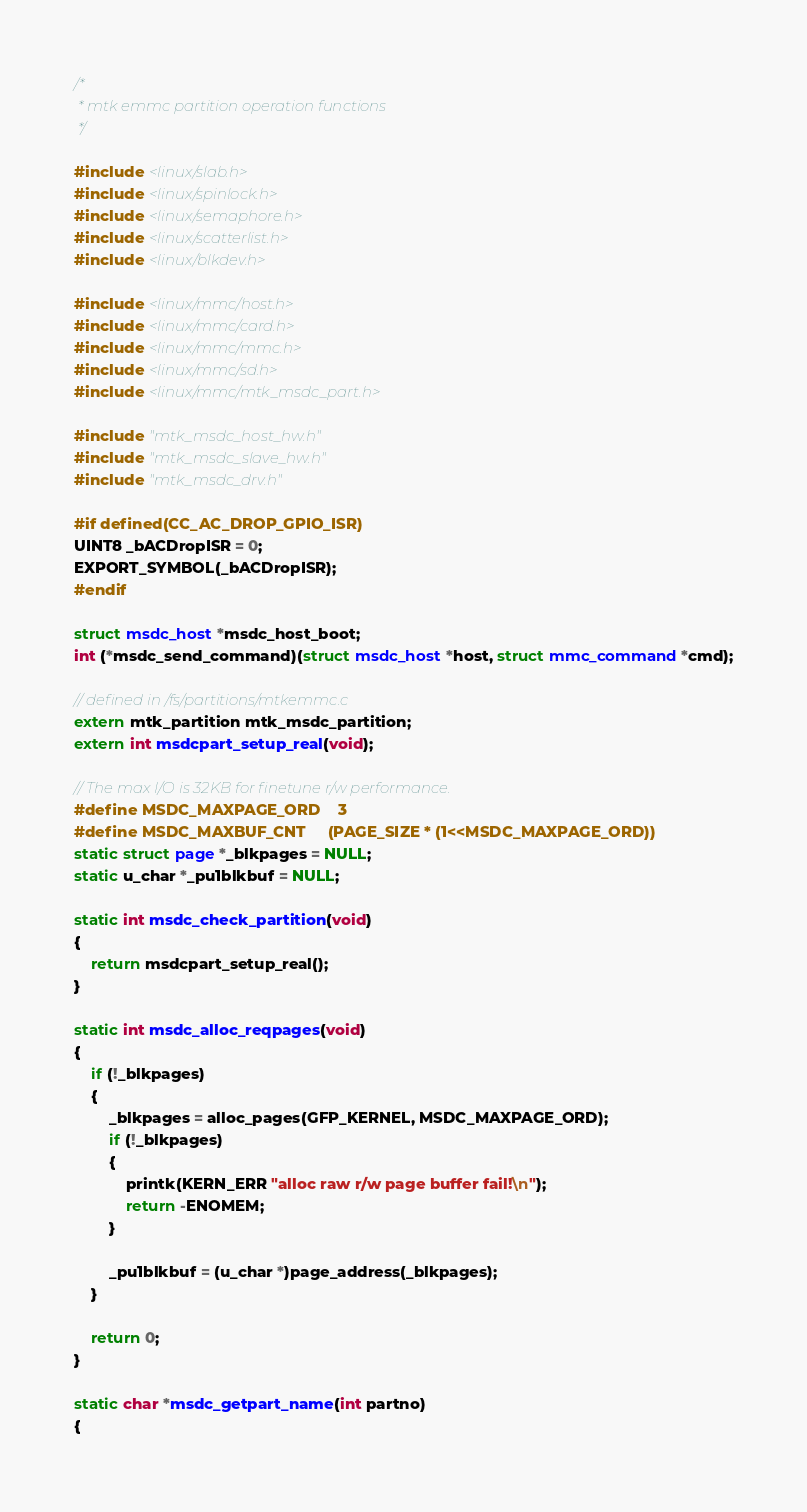<code> <loc_0><loc_0><loc_500><loc_500><_C_>/*
 * mtk emmc partition operation functions
 */

#include <linux/slab.h>
#include <linux/spinlock.h>
#include <linux/semaphore.h>
#include <linux/scatterlist.h>
#include <linux/blkdev.h>

#include <linux/mmc/host.h>
#include <linux/mmc/card.h>
#include <linux/mmc/mmc.h>
#include <linux/mmc/sd.h>
#include <linux/mmc/mtk_msdc_part.h>

#include "mtk_msdc_host_hw.h"
#include "mtk_msdc_slave_hw.h"
#include "mtk_msdc_drv.h"

#if defined(CC_AC_DROP_GPIO_ISR)
UINT8 _bACDropISR = 0;
EXPORT_SYMBOL(_bACDropISR);
#endif

struct msdc_host *msdc_host_boot;
int (*msdc_send_command)(struct msdc_host *host, struct mmc_command *cmd);

// defined in /fs/partitions/mtkemmc.c
extern mtk_partition mtk_msdc_partition;
extern int msdcpart_setup_real(void);

// The max I/O is 32KB for finetune r/w performance.
#define MSDC_MAXPAGE_ORD    3
#define MSDC_MAXBUF_CNT     (PAGE_SIZE * (1<<MSDC_MAXPAGE_ORD))
static struct page *_blkpages = NULL;
static u_char *_pu1blkbuf = NULL;

static int msdc_check_partition(void)
{
    return msdcpart_setup_real();
}

static int msdc_alloc_reqpages(void)
{
    if (!_blkpages)
    {
        _blkpages = alloc_pages(GFP_KERNEL, MSDC_MAXPAGE_ORD);
        if (!_blkpages)
        {
            printk(KERN_ERR "alloc raw r/w page buffer fail!\n");
            return -ENOMEM;
        }

        _pu1blkbuf = (u_char *)page_address(_blkpages);
    }

    return 0;
}

static char *msdc_getpart_name(int partno)
{</code> 